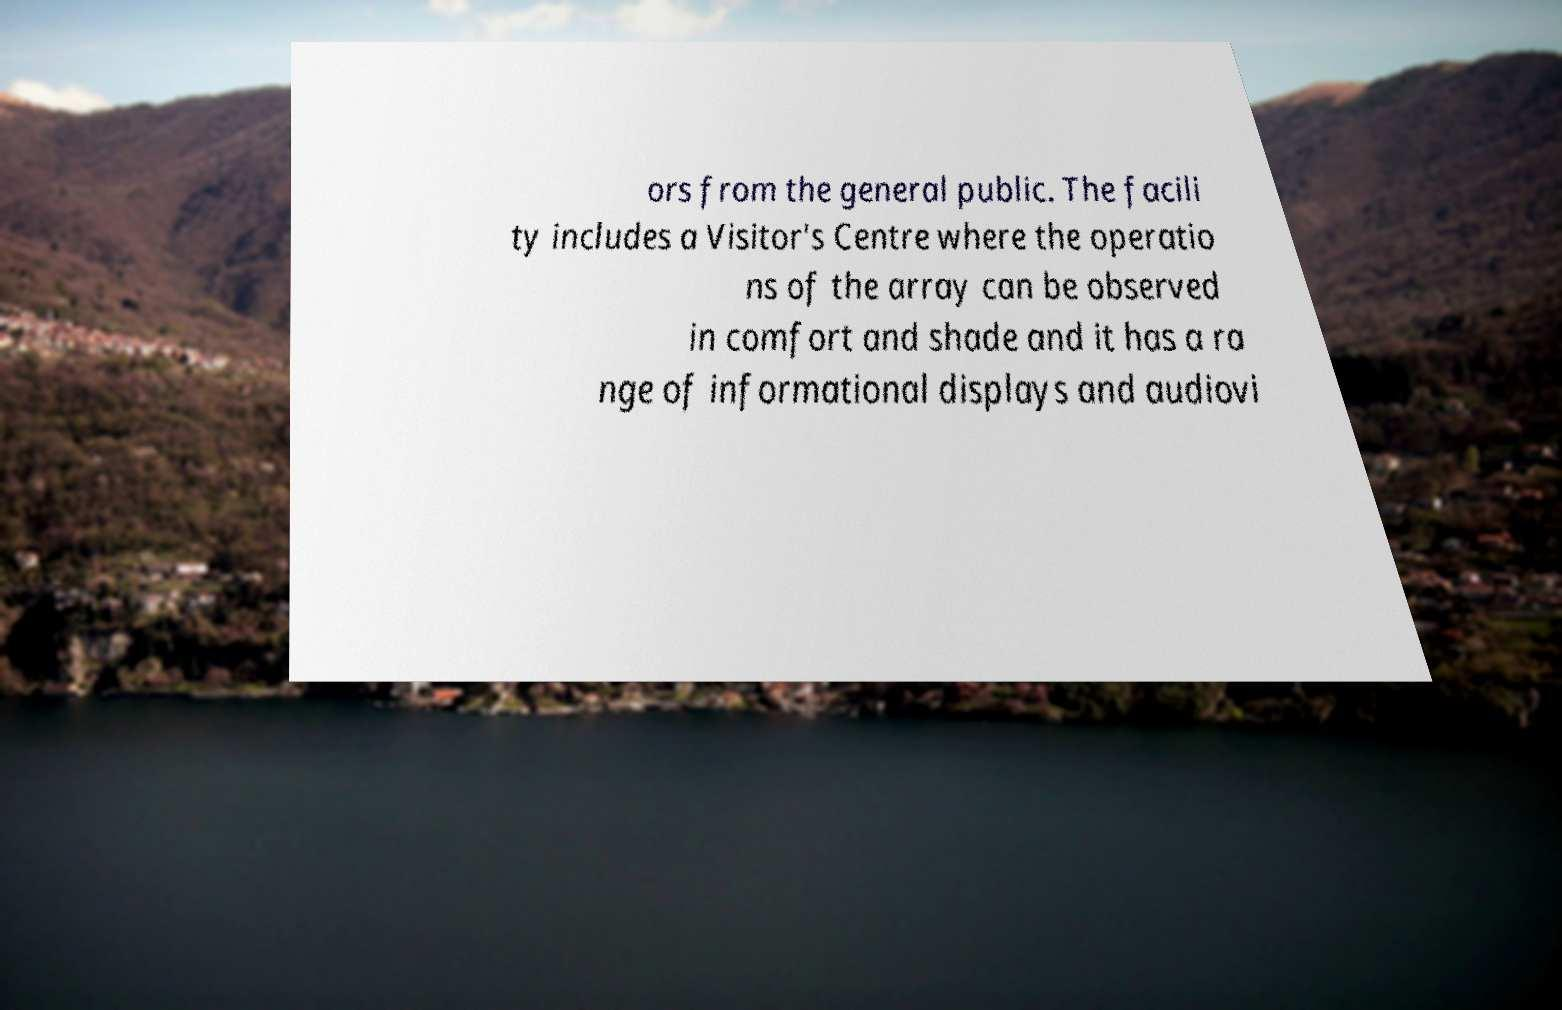For documentation purposes, I need the text within this image transcribed. Could you provide that? ors from the general public. The facili ty includes a Visitor's Centre where the operatio ns of the array can be observed in comfort and shade and it has a ra nge of informational displays and audiovi 